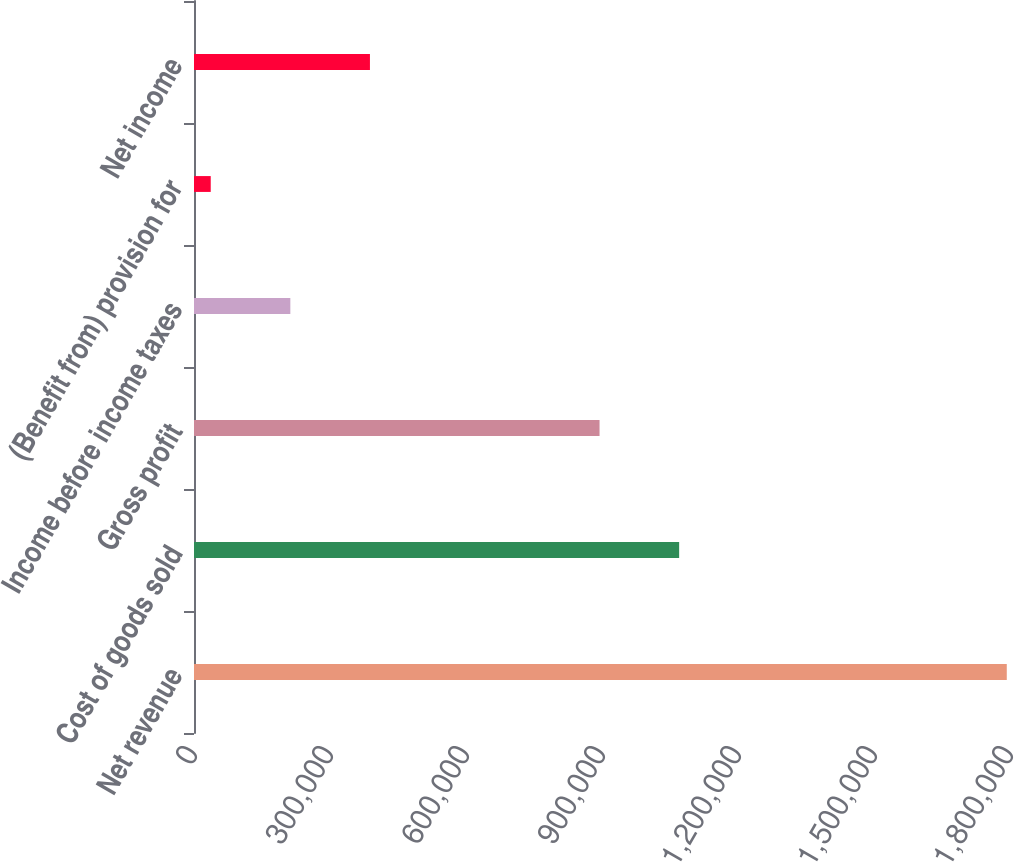<chart> <loc_0><loc_0><loc_500><loc_500><bar_chart><fcel>Net revenue<fcel>Cost of goods sold<fcel>Gross profit<fcel>Income before income taxes<fcel>(Benefit from) provision for<fcel>Net income<nl><fcel>1.79289e+06<fcel>1.07018e+06<fcel>894581<fcel>212506<fcel>36908<fcel>388105<nl></chart> 